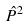Convert formula to latex. <formula><loc_0><loc_0><loc_500><loc_500>\hat { P } ^ { 2 }</formula> 